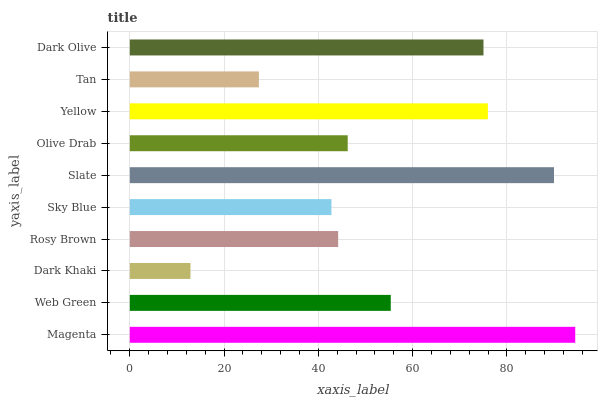Is Dark Khaki the minimum?
Answer yes or no. Yes. Is Magenta the maximum?
Answer yes or no. Yes. Is Web Green the minimum?
Answer yes or no. No. Is Web Green the maximum?
Answer yes or no. No. Is Magenta greater than Web Green?
Answer yes or no. Yes. Is Web Green less than Magenta?
Answer yes or no. Yes. Is Web Green greater than Magenta?
Answer yes or no. No. Is Magenta less than Web Green?
Answer yes or no. No. Is Web Green the high median?
Answer yes or no. Yes. Is Olive Drab the low median?
Answer yes or no. Yes. Is Dark Olive the high median?
Answer yes or no. No. Is Tan the low median?
Answer yes or no. No. 